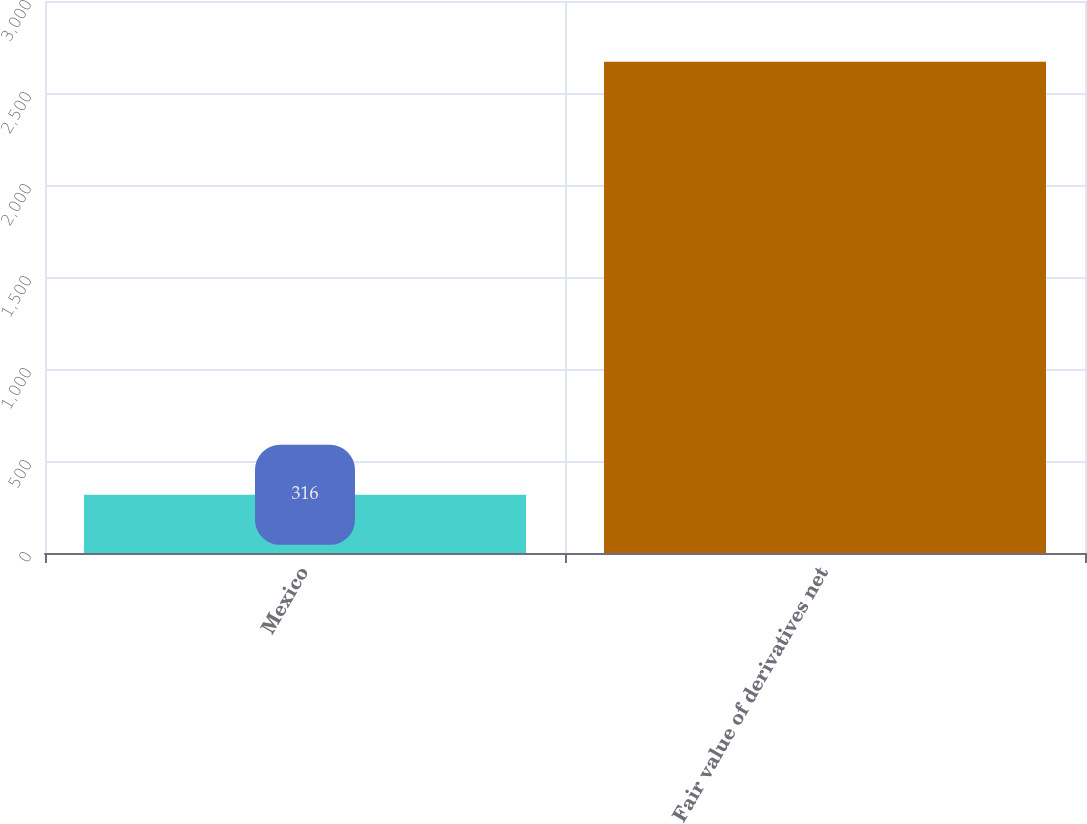Convert chart to OTSL. <chart><loc_0><loc_0><loc_500><loc_500><bar_chart><fcel>Mexico<fcel>Fair value of derivatives net<nl><fcel>316<fcel>2670<nl></chart> 